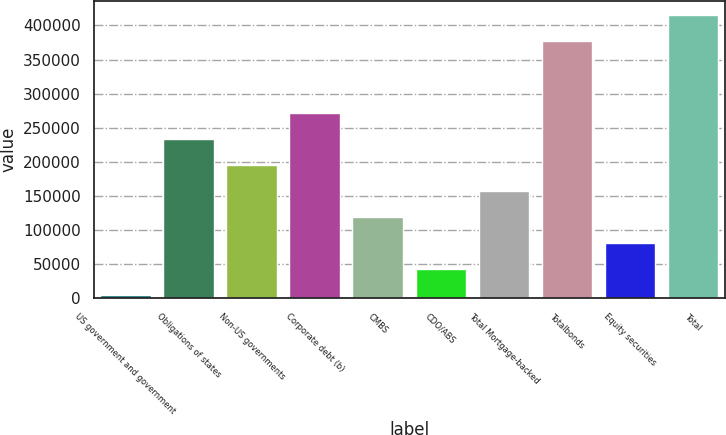<chart> <loc_0><loc_0><loc_500><loc_500><bar_chart><fcel>US government and government<fcel>Obligations of states<fcel>Non-US governments<fcel>Corporate debt (b)<fcel>CMBS<fcel>CDO/ABS<fcel>Total Mortgage-backed<fcel>Totalbonds<fcel>Equity securities<fcel>Total<nl><fcel>4433<fcel>233040<fcel>194938<fcel>271141<fcel>118736<fcel>42534.1<fcel>156837<fcel>377063<fcel>80635.2<fcel>415164<nl></chart> 